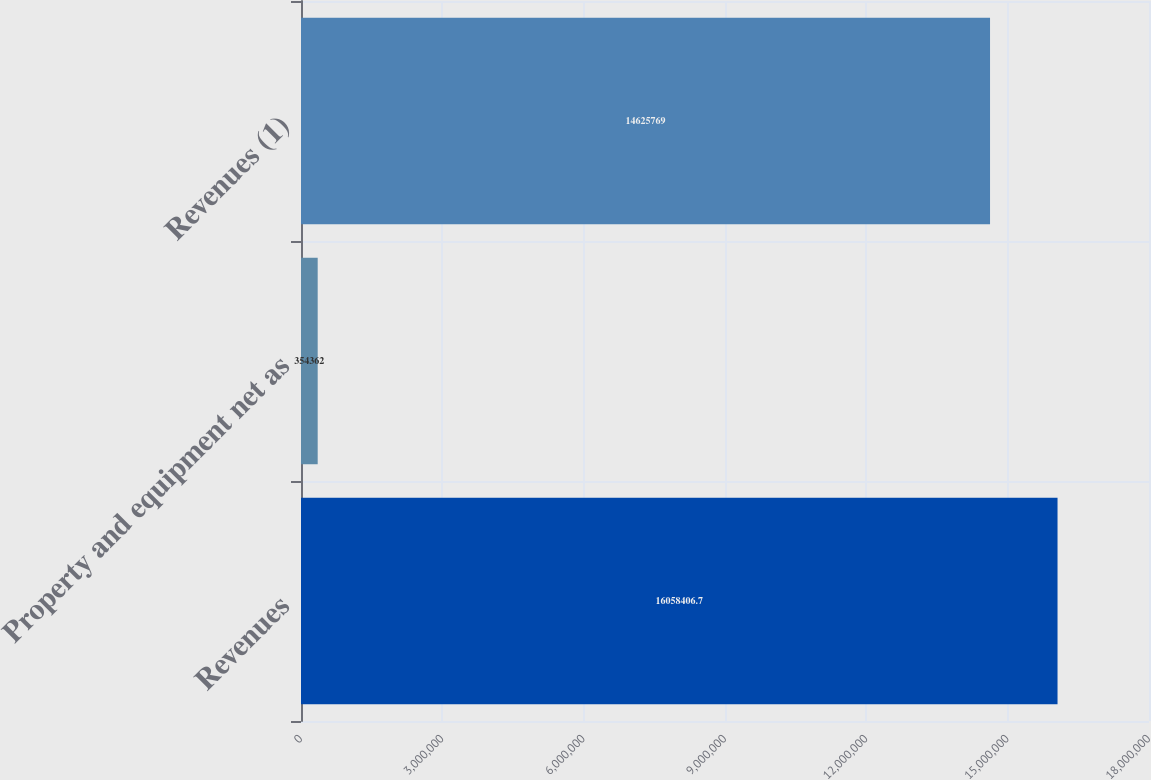Convert chart to OTSL. <chart><loc_0><loc_0><loc_500><loc_500><bar_chart><fcel>Revenues<fcel>Property and equipment net as<fcel>Revenues (1)<nl><fcel>1.60584e+07<fcel>354362<fcel>1.46258e+07<nl></chart> 